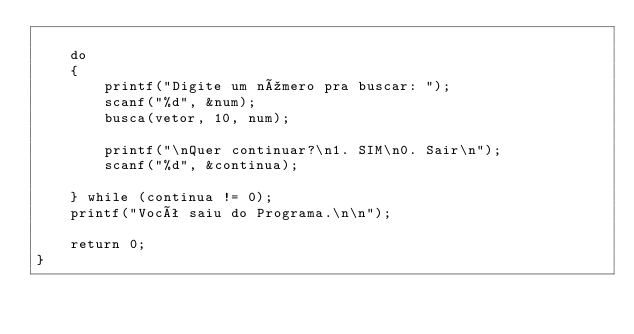<code> <loc_0><loc_0><loc_500><loc_500><_C_>    
    do
    {
        printf("Digite um número pra buscar: ");
        scanf("%d", &num);
        busca(vetor, 10, num);

        printf("\nQuer continuar?\n1. SIM\n0. Sair\n");
        scanf("%d", &continua);

    } while (continua != 0);
    printf("Você saiu do Programa.\n\n");
    
    return 0;
}
</code> 